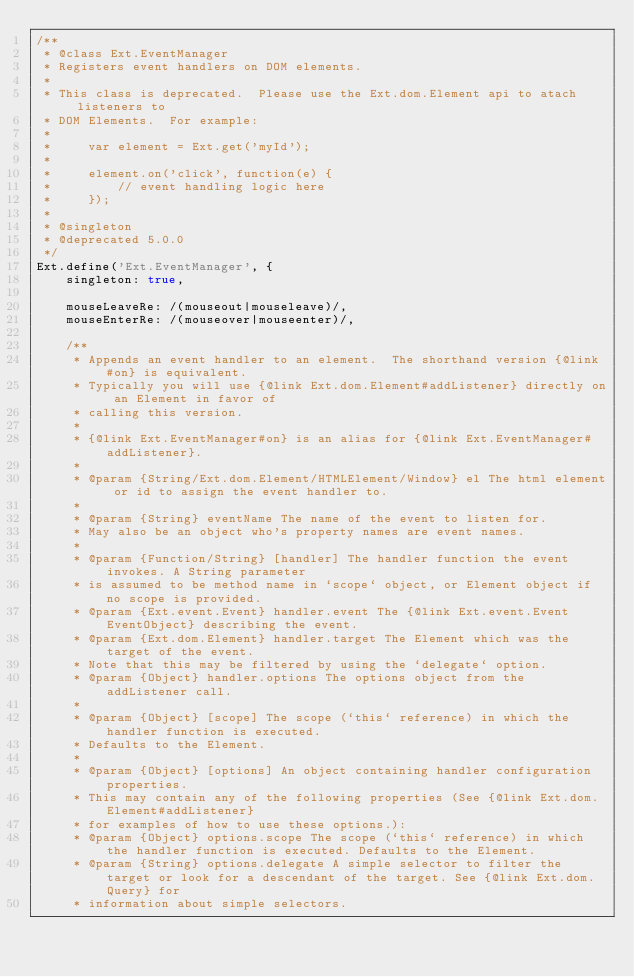<code> <loc_0><loc_0><loc_500><loc_500><_JavaScript_>/**
 * @class Ext.EventManager
 * Registers event handlers on DOM elements.
 * 
 * This class is deprecated.  Please use the Ext.dom.Element api to atach listeners to
 * DOM Elements.  For example:
 * 
 *     var element = Ext.get('myId');
 *     
 *     element.on('click', function(e) {
 *         // event handling logic here
 *     });
 *
 * @singleton
 * @deprecated 5.0.0
 */
Ext.define('Ext.EventManager', {
    singleton: true,

    mouseLeaveRe: /(mouseout|mouseleave)/,
    mouseEnterRe: /(mouseover|mouseenter)/,

    /**
     * Appends an event handler to an element.  The shorthand version {@link #on} is equivalent.
     * Typically you will use {@link Ext.dom.Element#addListener} directly on an Element in favor of
     * calling this version.
     *
     * {@link Ext.EventManager#on} is an alias for {@link Ext.EventManager#addListener}.
     *
     * @param {String/Ext.dom.Element/HTMLElement/Window} el The html element or id to assign the event handler to.
     *
     * @param {String} eventName The name of the event to listen for.
     * May also be an object who's property names are event names.
     *
     * @param {Function/String} [handler] The handler function the event invokes. A String parameter
     * is assumed to be method name in `scope` object, or Element object if no scope is provided.
     * @param {Ext.event.Event} handler.event The {@link Ext.event.Event EventObject} describing the event.
     * @param {Ext.dom.Element} handler.target The Element which was the target of the event.
     * Note that this may be filtered by using the `delegate` option.
     * @param {Object} handler.options The options object from the addListener call.
     *
     * @param {Object} [scope] The scope (`this` reference) in which the handler function is executed.
     * Defaults to the Element.
     *
     * @param {Object} [options] An object containing handler configuration properties.
     * This may contain any of the following properties (See {@link Ext.dom.Element#addListener}
     * for examples of how to use these options.):
     * @param {Object} options.scope The scope (`this` reference) in which the handler function is executed. Defaults to the Element.
     * @param {String} options.delegate A simple selector to filter the target or look for a descendant of the target. See {@link Ext.dom.Query} for
     * information about simple selectors.</code> 